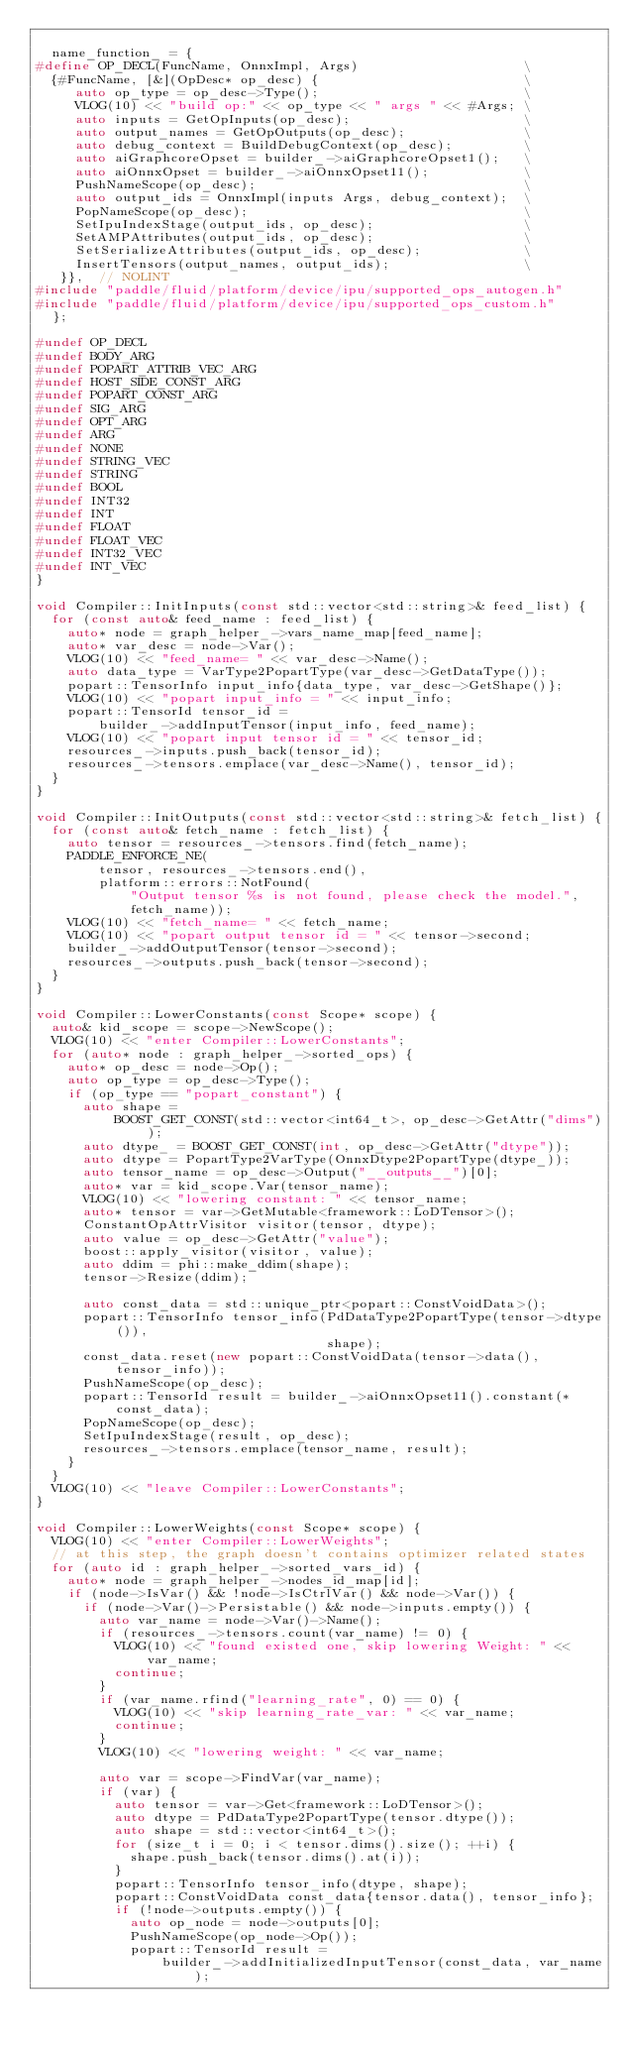Convert code to text. <code><loc_0><loc_0><loc_500><loc_500><_C++_>
  name_function_ = {
#define OP_DECL(FuncName, OnnxImpl, Args)                     \
  {#FuncName, [&](OpDesc* op_desc) {                          \
     auto op_type = op_desc->Type();                          \
     VLOG(10) << "build op:" << op_type << " args " << #Args; \
     auto inputs = GetOpInputs(op_desc);                      \
     auto output_names = GetOpOutputs(op_desc);               \
     auto debug_context = BuildDebugContext(op_desc);         \
     auto aiGraphcoreOpset = builder_->aiGraphcoreOpset1();   \
     auto aiOnnxOpset = builder_->aiOnnxOpset11();            \
     PushNameScope(op_desc);                                  \
     auto output_ids = OnnxImpl(inputs Args, debug_context);  \
     PopNameScope(op_desc);                                   \
     SetIpuIndexStage(output_ids, op_desc);                   \
     SetAMPAttributes(output_ids, op_desc);                   \
     SetSerializeAttributes(output_ids, op_desc);             \
     InsertTensors(output_names, output_ids);                 \
   }},  // NOLINT
#include "paddle/fluid/platform/device/ipu/supported_ops_autogen.h"
#include "paddle/fluid/platform/device/ipu/supported_ops_custom.h"
  };

#undef OP_DECL
#undef BODY_ARG
#undef POPART_ATTRIB_VEC_ARG
#undef HOST_SIDE_CONST_ARG
#undef POPART_CONST_ARG
#undef SIG_ARG
#undef OPT_ARG
#undef ARG
#undef NONE
#undef STRING_VEC
#undef STRING
#undef BOOL
#undef INT32
#undef INT
#undef FLOAT
#undef FLOAT_VEC
#undef INT32_VEC
#undef INT_VEC
}

void Compiler::InitInputs(const std::vector<std::string>& feed_list) {
  for (const auto& feed_name : feed_list) {
    auto* node = graph_helper_->vars_name_map[feed_name];
    auto* var_desc = node->Var();
    VLOG(10) << "feed_name= " << var_desc->Name();
    auto data_type = VarType2PopartType(var_desc->GetDataType());
    popart::TensorInfo input_info{data_type, var_desc->GetShape()};
    VLOG(10) << "popart input_info = " << input_info;
    popart::TensorId tensor_id =
        builder_->addInputTensor(input_info, feed_name);
    VLOG(10) << "popart input tensor id = " << tensor_id;
    resources_->inputs.push_back(tensor_id);
    resources_->tensors.emplace(var_desc->Name(), tensor_id);
  }
}

void Compiler::InitOutputs(const std::vector<std::string>& fetch_list) {
  for (const auto& fetch_name : fetch_list) {
    auto tensor = resources_->tensors.find(fetch_name);
    PADDLE_ENFORCE_NE(
        tensor, resources_->tensors.end(),
        platform::errors::NotFound(
            "Output tensor %s is not found, please check the model.",
            fetch_name));
    VLOG(10) << "fetch_name= " << fetch_name;
    VLOG(10) << "popart output tensor id = " << tensor->second;
    builder_->addOutputTensor(tensor->second);
    resources_->outputs.push_back(tensor->second);
  }
}

void Compiler::LowerConstants(const Scope* scope) {
  auto& kid_scope = scope->NewScope();
  VLOG(10) << "enter Compiler::LowerConstants";
  for (auto* node : graph_helper_->sorted_ops) {
    auto* op_desc = node->Op();
    auto op_type = op_desc->Type();
    if (op_type == "popart_constant") {
      auto shape =
          BOOST_GET_CONST(std::vector<int64_t>, op_desc->GetAttr("dims"));
      auto dtype_ = BOOST_GET_CONST(int, op_desc->GetAttr("dtype"));
      auto dtype = PopartType2VarType(OnnxDtype2PopartType(dtype_));
      auto tensor_name = op_desc->Output("__outputs__")[0];
      auto* var = kid_scope.Var(tensor_name);
      VLOG(10) << "lowering constant: " << tensor_name;
      auto* tensor = var->GetMutable<framework::LoDTensor>();
      ConstantOpAttrVisitor visitor(tensor, dtype);
      auto value = op_desc->GetAttr("value");
      boost::apply_visitor(visitor, value);
      auto ddim = phi::make_ddim(shape);
      tensor->Resize(ddim);

      auto const_data = std::unique_ptr<popart::ConstVoidData>();
      popart::TensorInfo tensor_info(PdDataType2PopartType(tensor->dtype()),
                                     shape);
      const_data.reset(new popart::ConstVoidData(tensor->data(), tensor_info));
      PushNameScope(op_desc);
      popart::TensorId result = builder_->aiOnnxOpset11().constant(*const_data);
      PopNameScope(op_desc);
      SetIpuIndexStage(result, op_desc);
      resources_->tensors.emplace(tensor_name, result);
    }
  }
  VLOG(10) << "leave Compiler::LowerConstants";
}

void Compiler::LowerWeights(const Scope* scope) {
  VLOG(10) << "enter Compiler::LowerWeights";
  // at this step, the graph doesn't contains optimizer related states
  for (auto id : graph_helper_->sorted_vars_id) {
    auto* node = graph_helper_->nodes_id_map[id];
    if (node->IsVar() && !node->IsCtrlVar() && node->Var()) {
      if (node->Var()->Persistable() && node->inputs.empty()) {
        auto var_name = node->Var()->Name();
        if (resources_->tensors.count(var_name) != 0) {
          VLOG(10) << "found existed one, skip lowering Weight: " << var_name;
          continue;
        }
        if (var_name.rfind("learning_rate", 0) == 0) {
          VLOG(10) << "skip learning_rate_var: " << var_name;
          continue;
        }
        VLOG(10) << "lowering weight: " << var_name;

        auto var = scope->FindVar(var_name);
        if (var) {
          auto tensor = var->Get<framework::LoDTensor>();
          auto dtype = PdDataType2PopartType(tensor.dtype());
          auto shape = std::vector<int64_t>();
          for (size_t i = 0; i < tensor.dims().size(); ++i) {
            shape.push_back(tensor.dims().at(i));
          }
          popart::TensorInfo tensor_info(dtype, shape);
          popart::ConstVoidData const_data{tensor.data(), tensor_info};
          if (!node->outputs.empty()) {
            auto op_node = node->outputs[0];
            PushNameScope(op_node->Op());
            popart::TensorId result =
                builder_->addInitializedInputTensor(const_data, var_name);</code> 